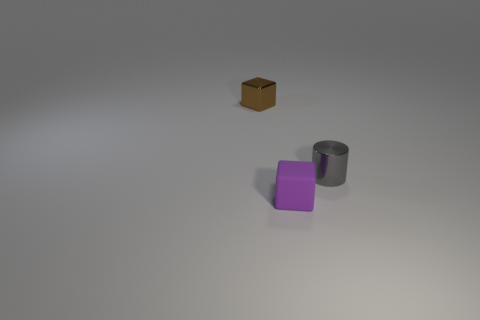Is there any other thing that has the same color as the matte thing?
Give a very brief answer. No. Do the thing that is left of the purple object and the block that is on the right side of the tiny brown metallic object have the same material?
Your answer should be compact. No. How many large purple rubber balls are there?
Your answer should be compact. 0. How many other tiny things are the same shape as the tiny gray shiny object?
Ensure brevity in your answer.  0. Do the small gray object and the tiny purple object have the same shape?
Provide a succinct answer. No. The gray metallic cylinder is what size?
Offer a very short reply. Small. How many things are the same size as the cylinder?
Your response must be concise. 2. There is a cube that is behind the tiny purple thing; does it have the same size as the block that is in front of the brown block?
Keep it short and to the point. Yes. There is a shiny thing to the left of the gray metallic cylinder; what shape is it?
Keep it short and to the point. Cube. What is the block in front of the tiny metal object that is on the left side of the small rubber cube made of?
Provide a short and direct response. Rubber. 